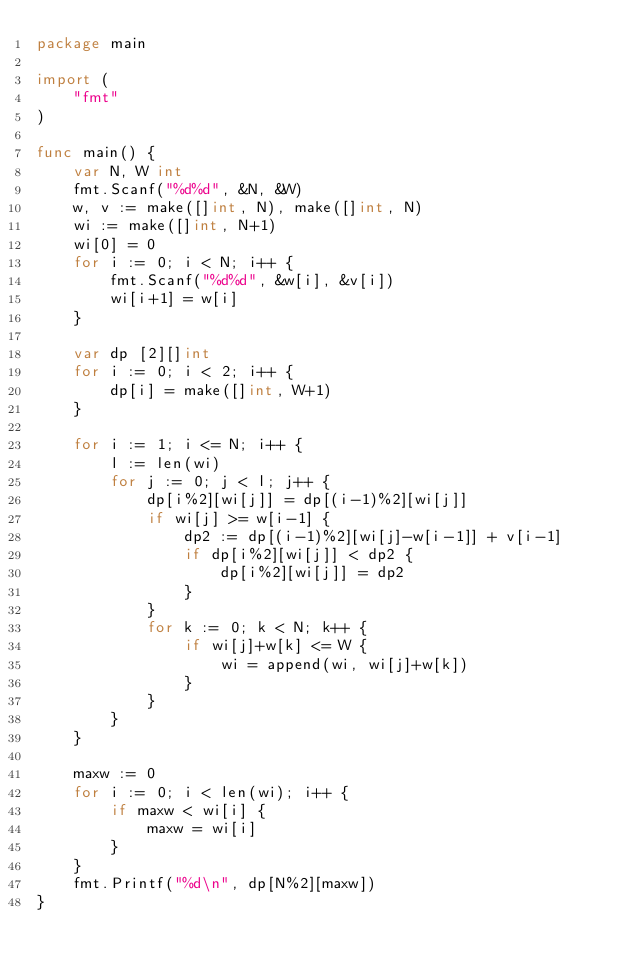<code> <loc_0><loc_0><loc_500><loc_500><_Go_>package main

import (
	"fmt"
)

func main() {
	var N, W int
	fmt.Scanf("%d%d", &N, &W)
	w, v := make([]int, N), make([]int, N)
	wi := make([]int, N+1)
	wi[0] = 0
	for i := 0; i < N; i++ {
		fmt.Scanf("%d%d", &w[i], &v[i])
		wi[i+1] = w[i]
	}

	var dp [2][]int
	for i := 0; i < 2; i++ {
		dp[i] = make([]int, W+1)
	}

	for i := 1; i <= N; i++ {
		l := len(wi)
		for j := 0; j < l; j++ {
			dp[i%2][wi[j]] = dp[(i-1)%2][wi[j]]
			if wi[j] >= w[i-1] {
				dp2 := dp[(i-1)%2][wi[j]-w[i-1]] + v[i-1]
				if dp[i%2][wi[j]] < dp2 {
					dp[i%2][wi[j]] = dp2
				}
			}
			for k := 0; k < N; k++ {
				if wi[j]+w[k] <= W {
					wi = append(wi, wi[j]+w[k])
				}
			}
		}
	}

	maxw := 0
	for i := 0; i < len(wi); i++ {
		if maxw < wi[i] {
			maxw = wi[i]
		}
	}
	fmt.Printf("%d\n", dp[N%2][maxw])
}
</code> 